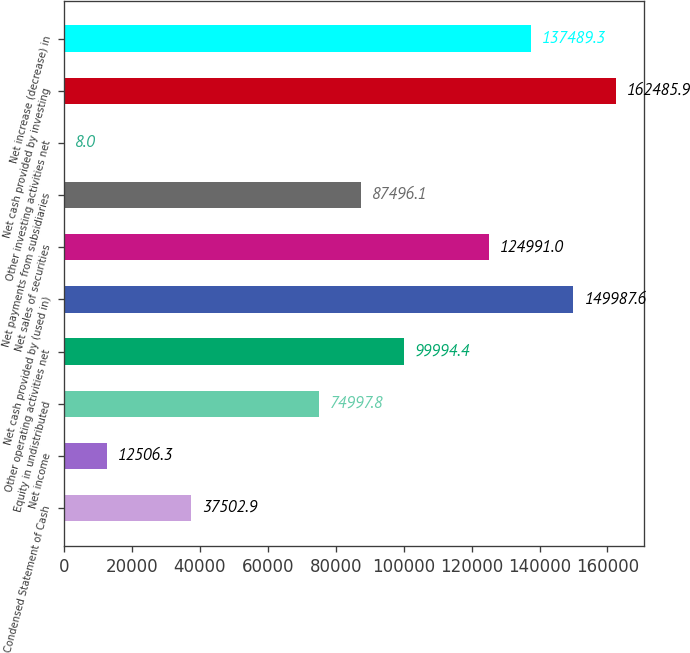Convert chart to OTSL. <chart><loc_0><loc_0><loc_500><loc_500><bar_chart><fcel>Condensed Statement of Cash<fcel>Net income<fcel>Equity in undistributed<fcel>Other operating activities net<fcel>Net cash provided by (used in)<fcel>Net sales of securities<fcel>Net payments from subsidiaries<fcel>Other investing activities net<fcel>Net cash provided by investing<fcel>Net increase (decrease) in<nl><fcel>37502.9<fcel>12506.3<fcel>74997.8<fcel>99994.4<fcel>149988<fcel>124991<fcel>87496.1<fcel>8<fcel>162486<fcel>137489<nl></chart> 